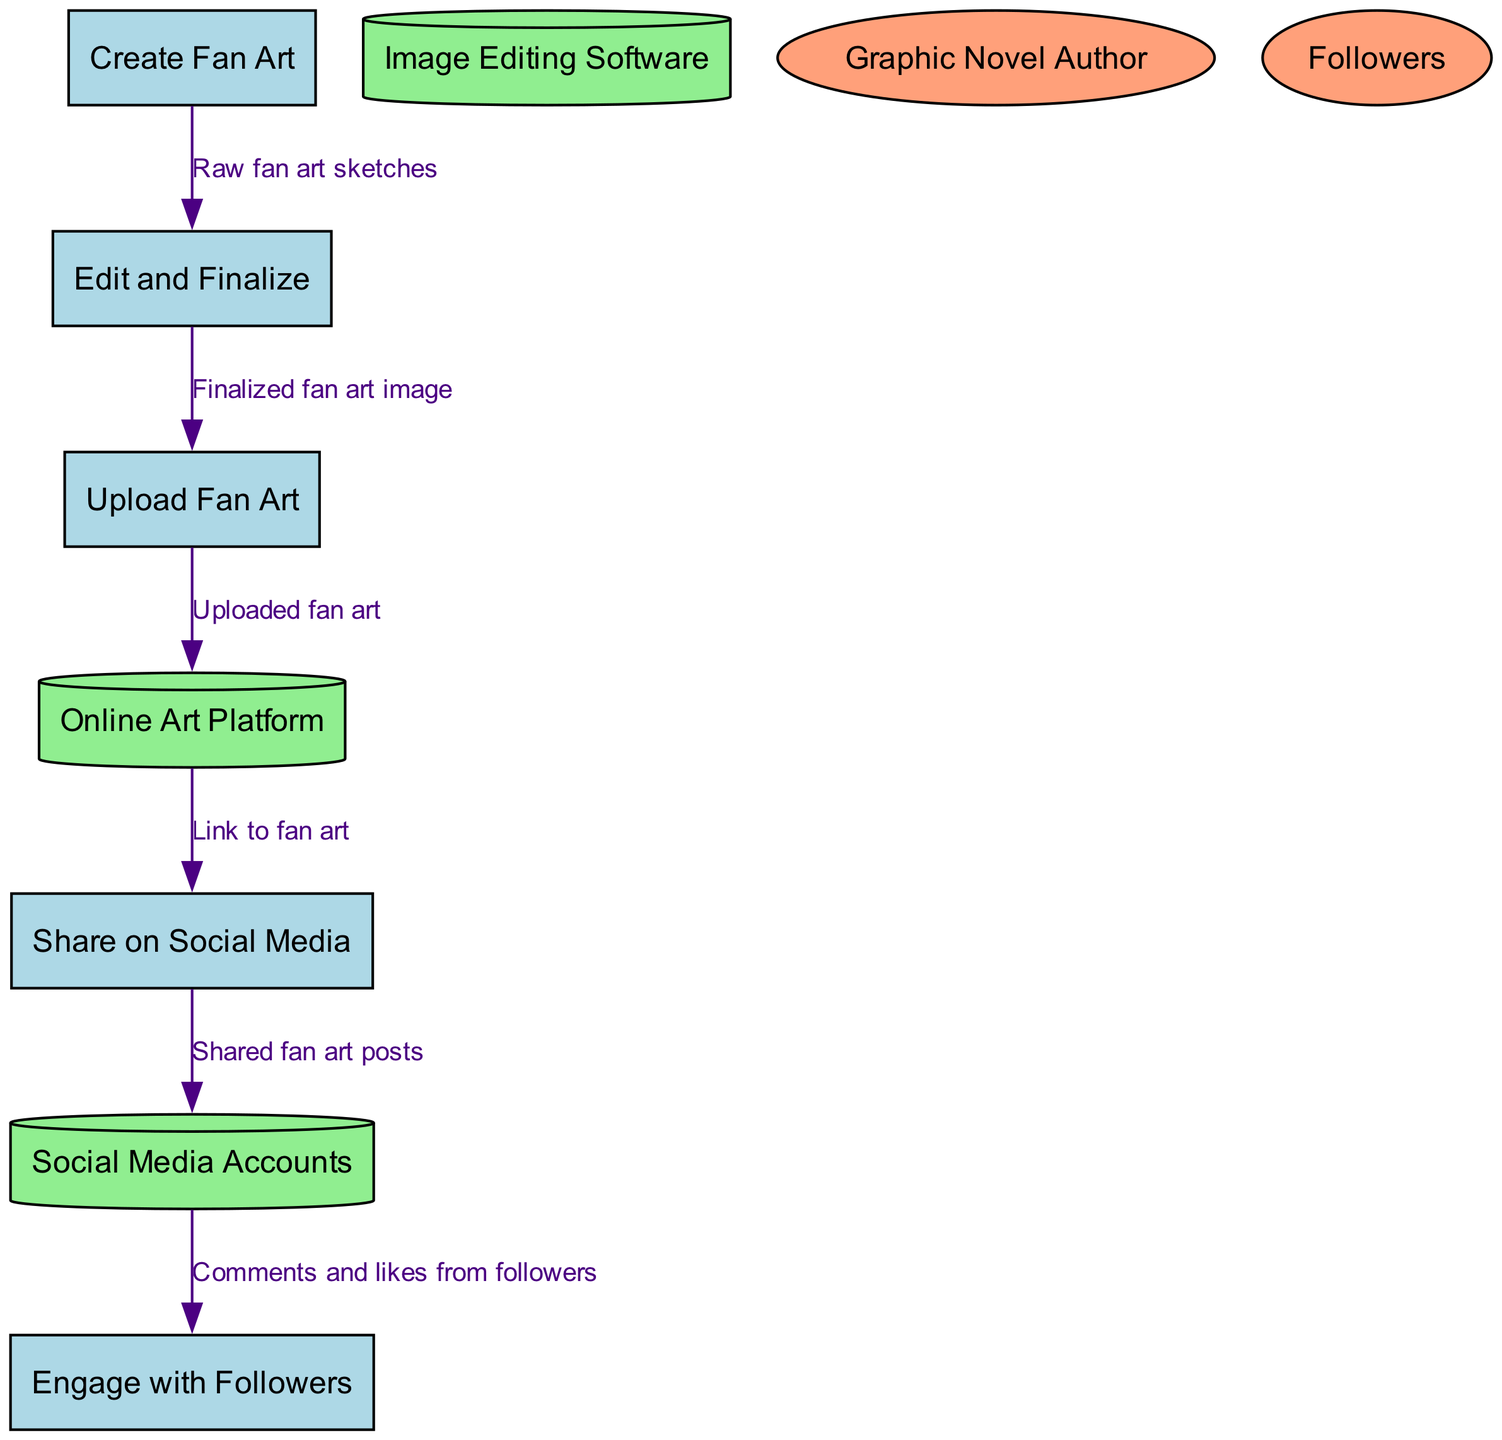What is the first process in the diagram? The first process listed in the diagram is "Create Fan Art," as it is the starting point of the fan art creation and distribution sequence.
Answer: Create Fan Art How many data stores are present in the diagram? There are three data stores mentioned in the diagram, which include "Image Editing Software," "Online Art Platform," and "Social Media Accounts."
Answer: 3 Which process is responsible for uploading the fan art? The process responsible for uploading the fan art is "Upload Fan Art," as indicated by the flow that connects this process directly to the data store "Online Art Platform."
Answer: Upload Fan Art What data is shared between "Share on Social Media" and "Social Media Accounts"? The data shared between "Share on Social Media" and "Social Media Accounts" is the "Shared fan art posts," which moves from the process to the accounts.
Answer: Shared fan art posts What is the final step before engaging with followers? The final step before engaging with followers is "Share on Social Media," which allows for posts to be made and subsequently receive comments and likes.
Answer: Share on Social Media How does the "Edit and Finalize" process relate to "Create Fan Art"? The "Edit and Finalize" process receives "Raw fan art sketches" from the "Create Fan Art" process, indicating that it is a direct follow-up step for refinement.
Answer: Raw fan art sketches What external entity provides source material for the fan art? The external entity that provides source material for the fan art is the "Graphic Novel Author," as they are mentioned as a source of input in the fan art process.
Answer: Graphic Novel Author Which process comes after "Edit and Finalize"? The process that comes after "Edit and Finalize" is "Upload Fan Art," as indicated by the sequential flow from one to the other for finalizing and then uploading.
Answer: Upload Fan Art What type of diagram is being described? The type of diagram being described is a "Data Flow Diagram," which showcases the flow of data through various processes, stores, and external entities.
Answer: Data Flow Diagram 